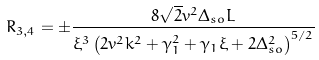Convert formula to latex. <formula><loc_0><loc_0><loc_500><loc_500>R _ { 3 , 4 } = \pm \frac { 8 \sqrt { 2 } v ^ { 2 } \Delta _ { s o } L } { \xi ^ { 3 } \left ( 2 v ^ { 2 } k ^ { 2 } + \gamma _ { 1 } ^ { 2 } + \gamma _ { 1 } \xi + 2 \Delta _ { s o } ^ { 2 } \right ) ^ { 5 / 2 } }</formula> 